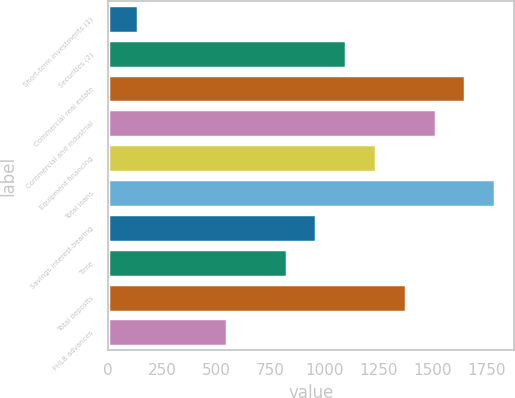<chart> <loc_0><loc_0><loc_500><loc_500><bar_chart><fcel>Short-term investments (1)<fcel>Securities (2)<fcel>Commercial real estate<fcel>Commercial and industrial<fcel>Equipment financing<fcel>Total loans<fcel>Savings interest-bearing<fcel>Time<fcel>Total deposits<fcel>FHLB advances<nl><fcel>138.58<fcel>1101.64<fcel>1651.96<fcel>1514.38<fcel>1239.22<fcel>1789.54<fcel>964.06<fcel>826.48<fcel>1376.8<fcel>551.32<nl></chart> 